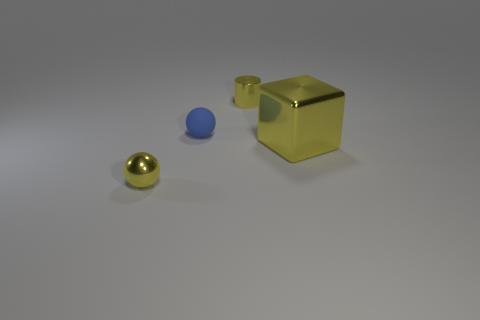Add 4 small metal cylinders. How many objects exist? 8 Subtract all cylinders. How many objects are left? 3 Subtract all small metallic cylinders. Subtract all gray metallic cylinders. How many objects are left? 3 Add 3 yellow shiny blocks. How many yellow shiny blocks are left? 4 Add 4 big blocks. How many big blocks exist? 5 Subtract 1 yellow balls. How many objects are left? 3 